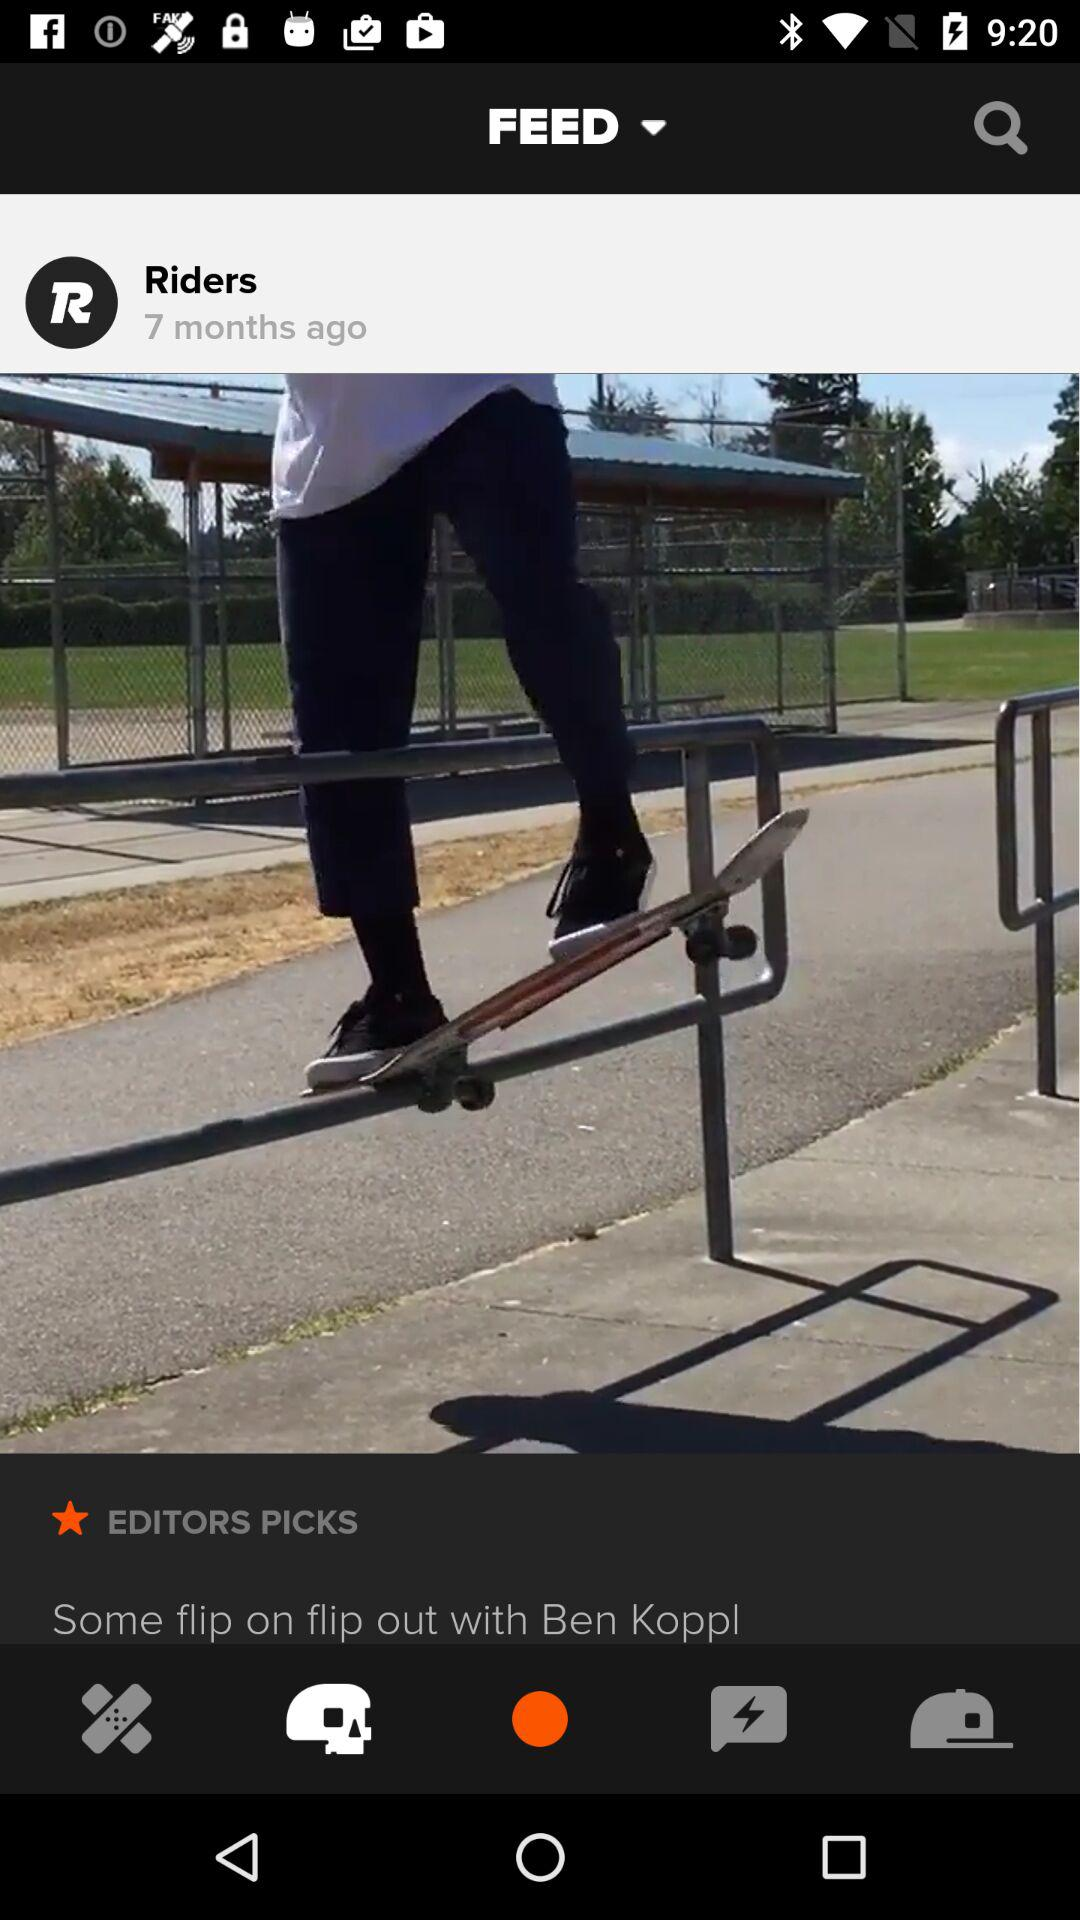How many months ago was the post posted? The post was posted 7 months ago. 